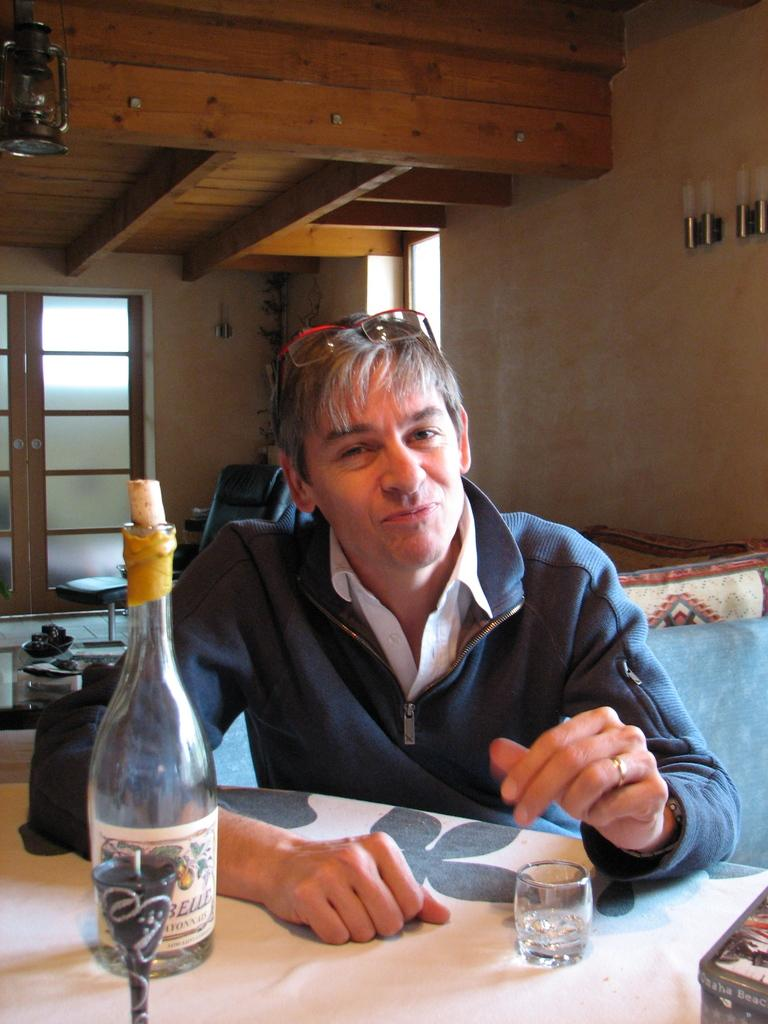What is the man in the image doing? The man is seated on a chair in the image. What objects are on the table in the image? There is a bottle and glasses on the table in the image. What type of oil is being used to play with the man in the image? There is no oil or playing activity present in the image. 